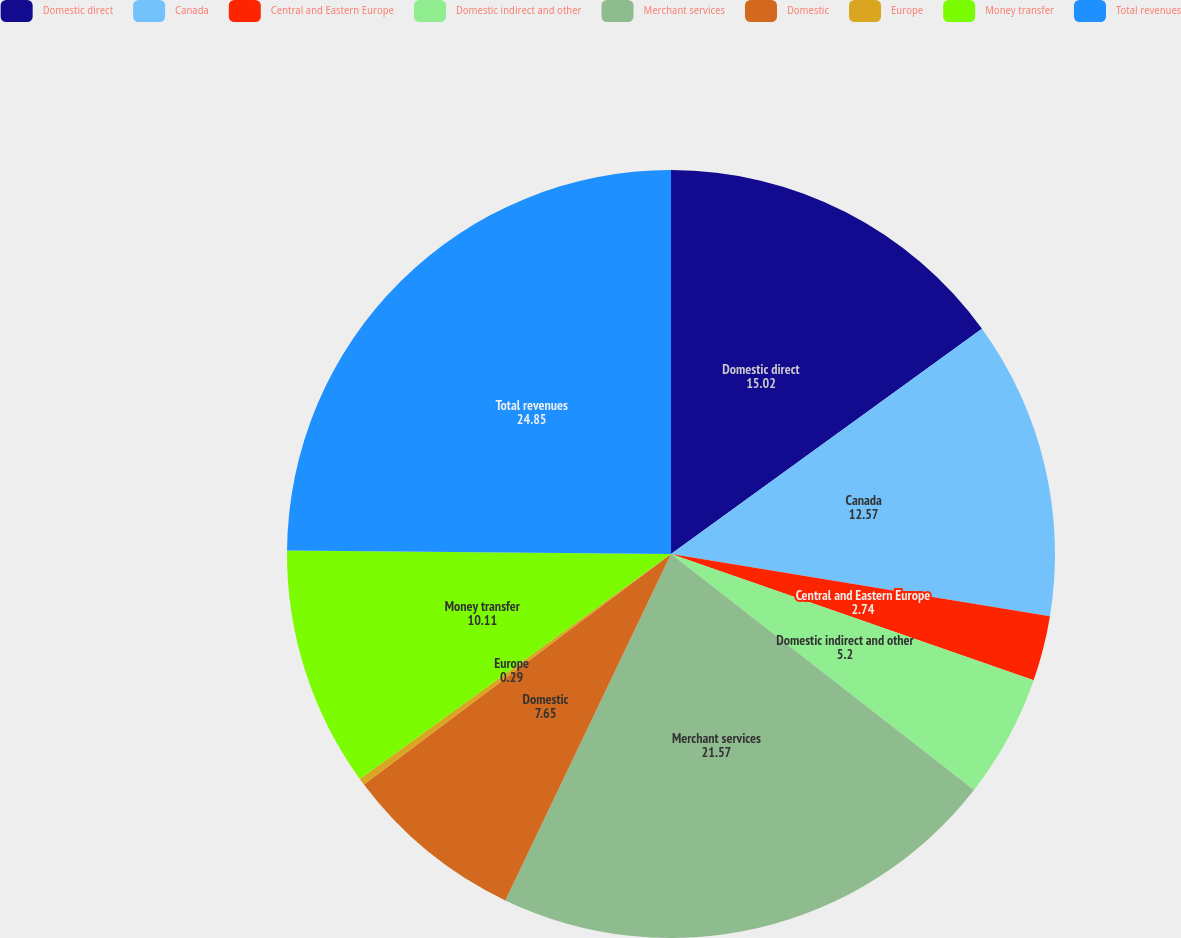Convert chart to OTSL. <chart><loc_0><loc_0><loc_500><loc_500><pie_chart><fcel>Domestic direct<fcel>Canada<fcel>Central and Eastern Europe<fcel>Domestic indirect and other<fcel>Merchant services<fcel>Domestic<fcel>Europe<fcel>Money transfer<fcel>Total revenues<nl><fcel>15.02%<fcel>12.57%<fcel>2.74%<fcel>5.2%<fcel>21.57%<fcel>7.65%<fcel>0.29%<fcel>10.11%<fcel>24.85%<nl></chart> 